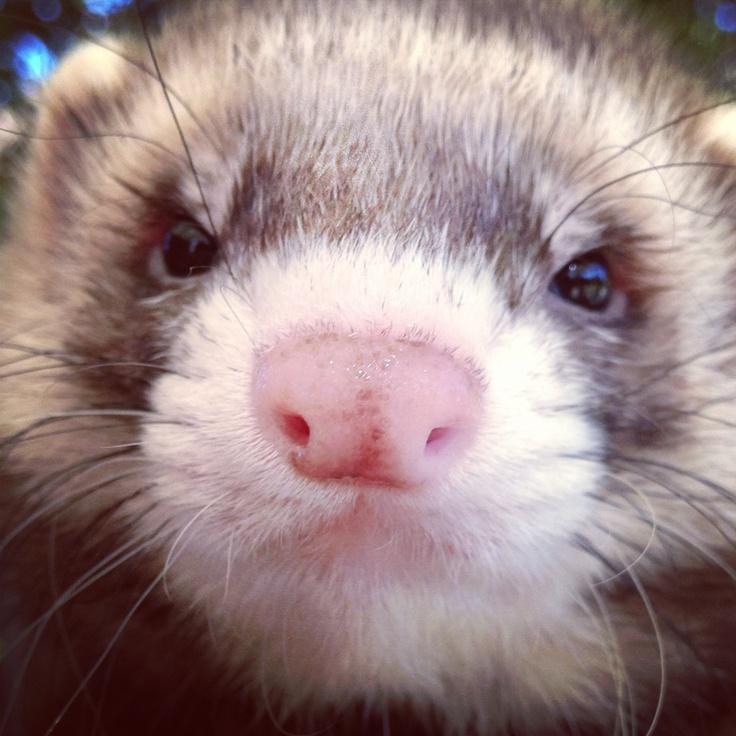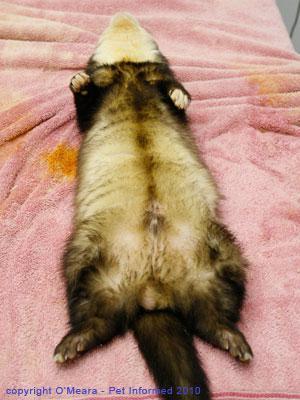The first image is the image on the left, the second image is the image on the right. Considering the images on both sides, is "The left image contains two ferrets." valid? Answer yes or no. No. The first image is the image on the left, the second image is the image on the right. Assess this claim about the two images: "The left image contains two ferrets with their faces close together and their mouths open to some degree.". Correct or not? Answer yes or no. No. 